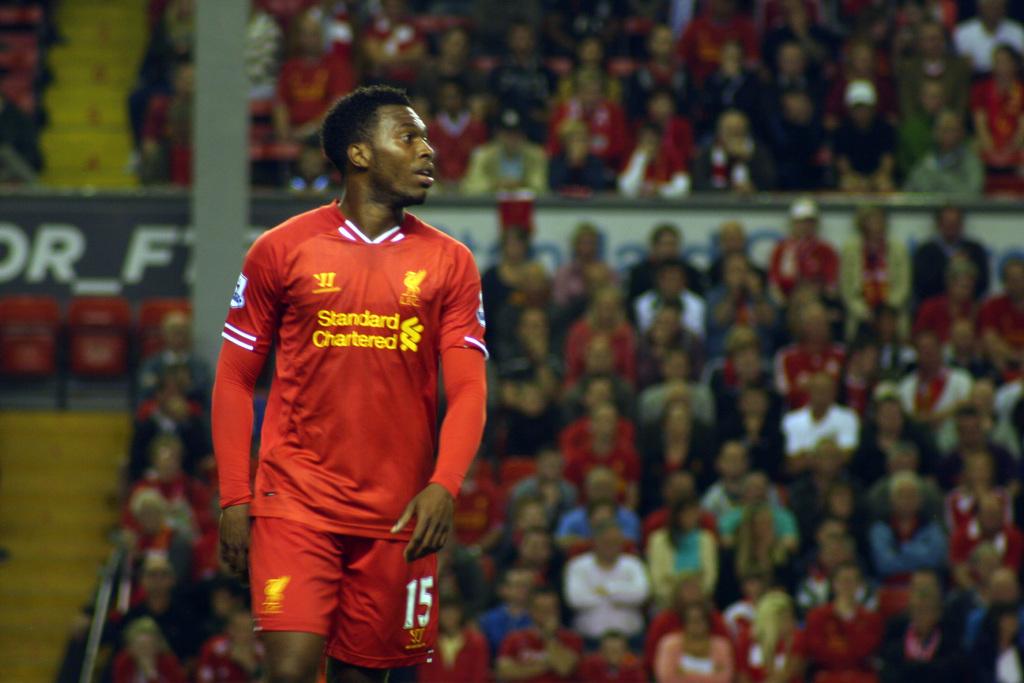What number is the player?
Keep it short and to the point. 15. 